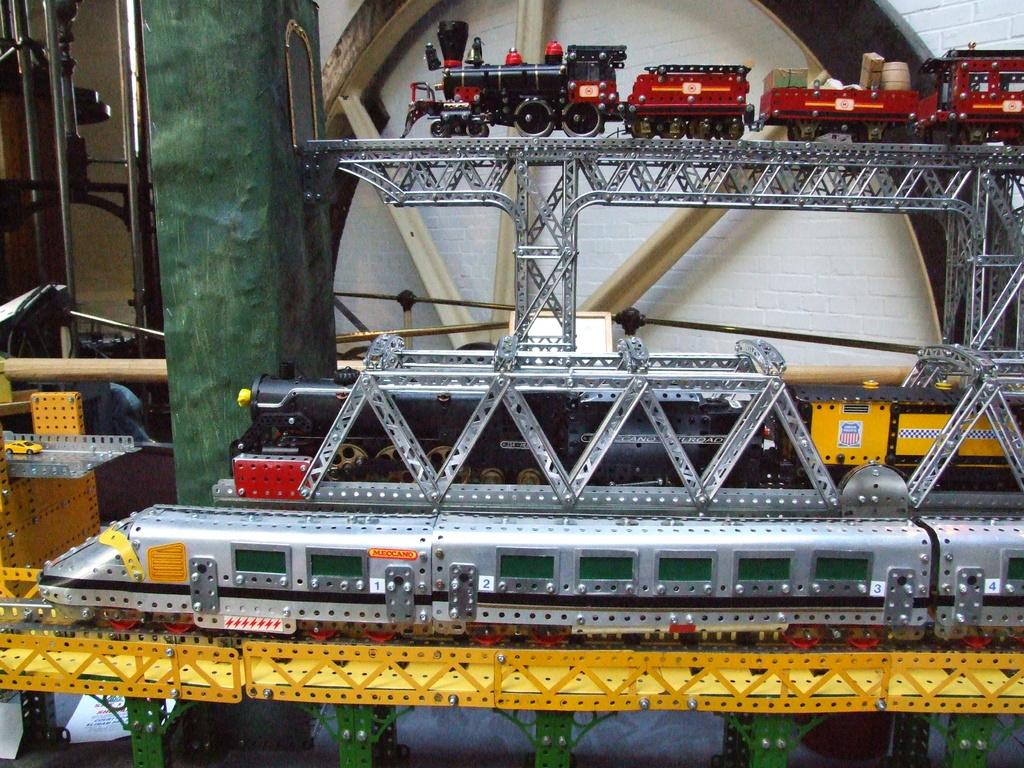What type of toys are present in the image? There are train toys in the image. Can you describe the appearance of the train toys? The train toys are of different colors. How are the train toys arranged in the image? The train toys are arranged on tracks. What can be seen behind the train toys in the image? There is a door visible behind the trains. What type of furniture is present in the image? There is no furniture present in the image; it features train toys arranged on tracks with a door visible behind them. 